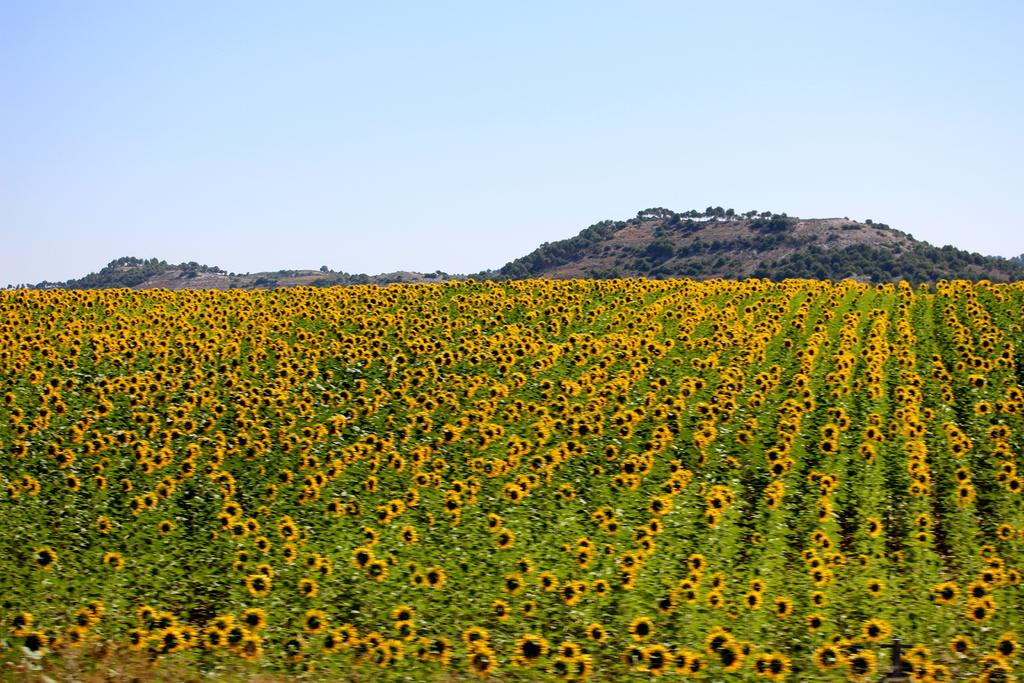What type of plants can be seen in the image? There are sunflower plants in the image. What can be seen in the distance behind the plants? There are hills in the background of the image. What type of vegetation is present on the hills? There are trees on the hills. What is the condition of the sky in the image? The sky is clear in the image. How many trucks are parked near the sunflower plants in the image? There are no trucks present in the image; it features sunflower plants, hills, trees, and a clear sky. 